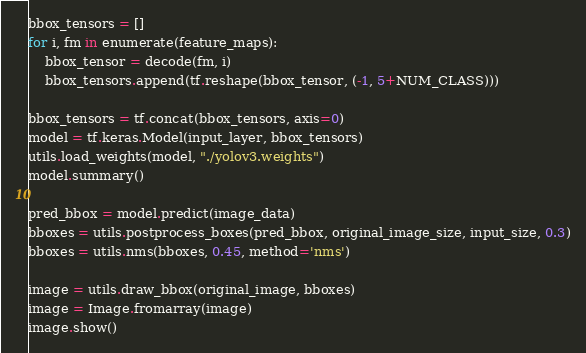Convert code to text. <code><loc_0><loc_0><loc_500><loc_500><_Python_>bbox_tensors = []
for i, fm in enumerate(feature_maps):
    bbox_tensor = decode(fm, i)
    bbox_tensors.append(tf.reshape(bbox_tensor, (-1, 5+NUM_CLASS)))

bbox_tensors = tf.concat(bbox_tensors, axis=0)
model = tf.keras.Model(input_layer, bbox_tensors)
utils.load_weights(model, "./yolov3.weights")
model.summary()

pred_bbox = model.predict(image_data)
bboxes = utils.postprocess_boxes(pred_bbox, original_image_size, input_size, 0.3)
bboxes = utils.nms(bboxes, 0.45, method='nms')

image = utils.draw_bbox(original_image, bboxes)
image = Image.fromarray(image)
image.show()


</code> 